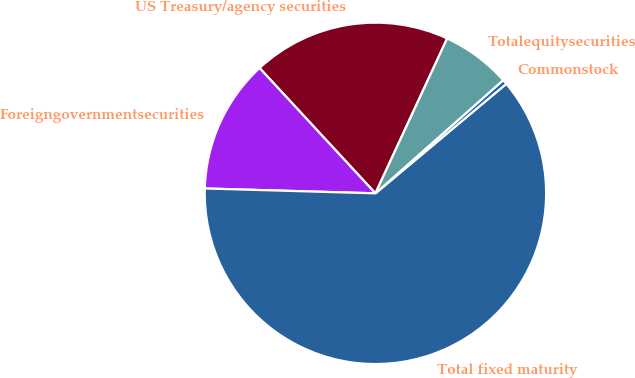Convert chart to OTSL. <chart><loc_0><loc_0><loc_500><loc_500><pie_chart><fcel>US Treasury/agency securities<fcel>Foreigngovernmentsecurities<fcel>Total fixed maturity<fcel>Commonstock<fcel>Totalequitysecurities<nl><fcel>18.78%<fcel>12.67%<fcel>61.55%<fcel>0.45%<fcel>6.56%<nl></chart> 